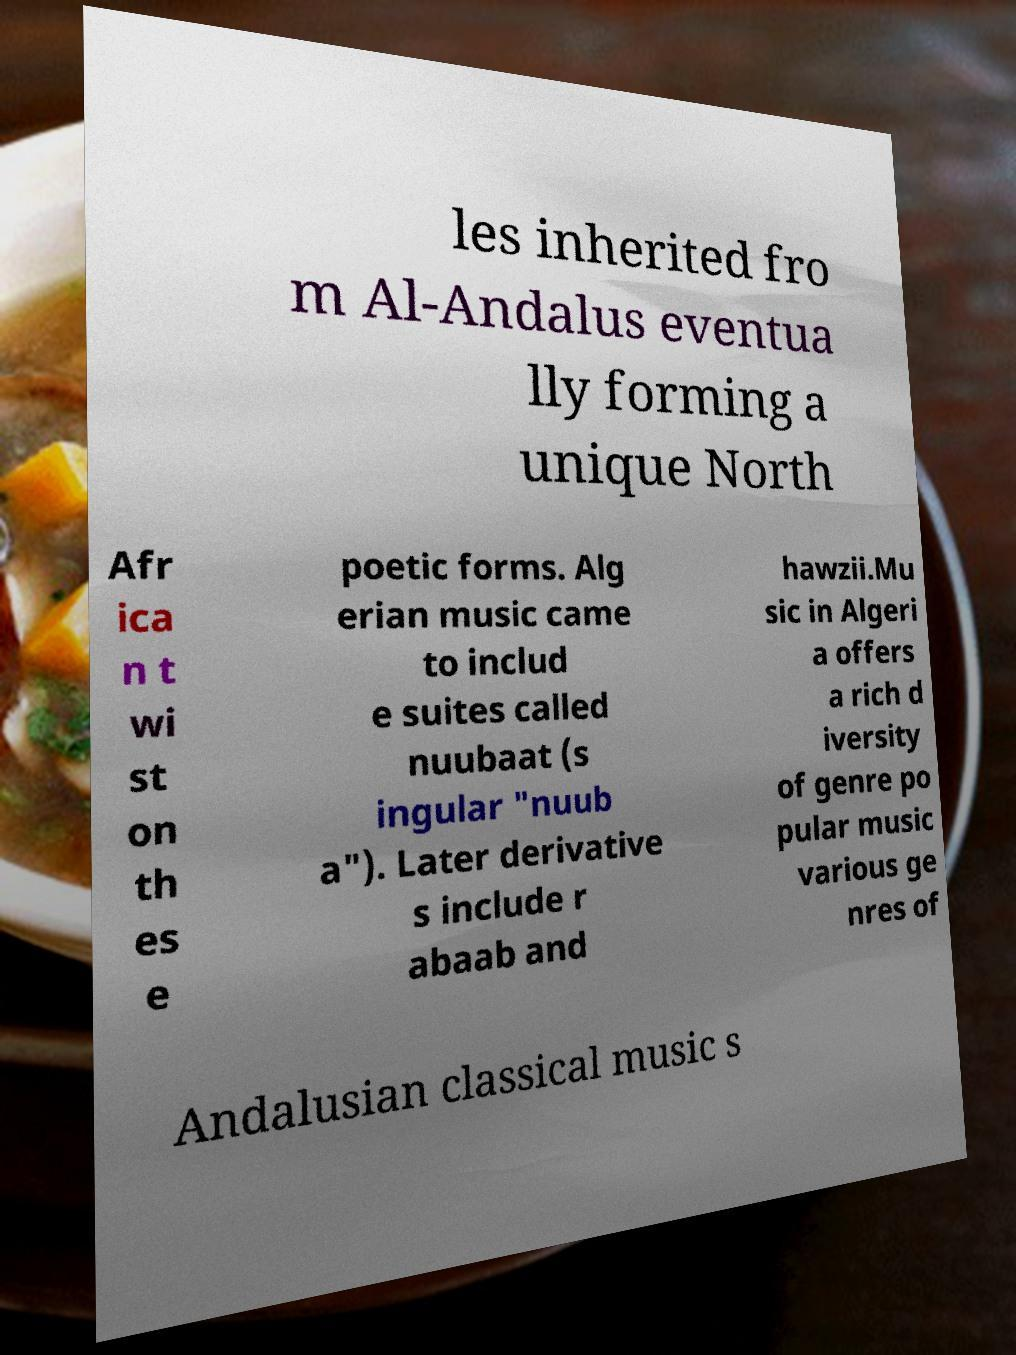Please identify and transcribe the text found in this image. les inherited fro m Al-Andalus eventua lly forming a unique North Afr ica n t wi st on th es e poetic forms. Alg erian music came to includ e suites called nuubaat (s ingular "nuub a"). Later derivative s include r abaab and hawzii.Mu sic in Algeri a offers a rich d iversity of genre po pular music various ge nres of Andalusian classical music s 